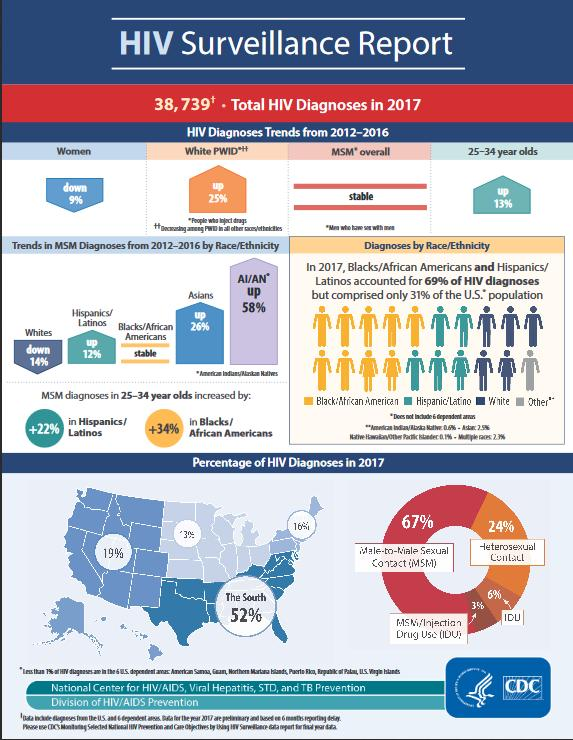Mention a couple of crucial points in this snapshot. The South region of the United States had the highest percentage of HIV diagnoses in 2017. The second highest reason for transmission, as demonstrated in the chart, is heterosexual contact. The trend for HIV diagnoses among women has decreased. 